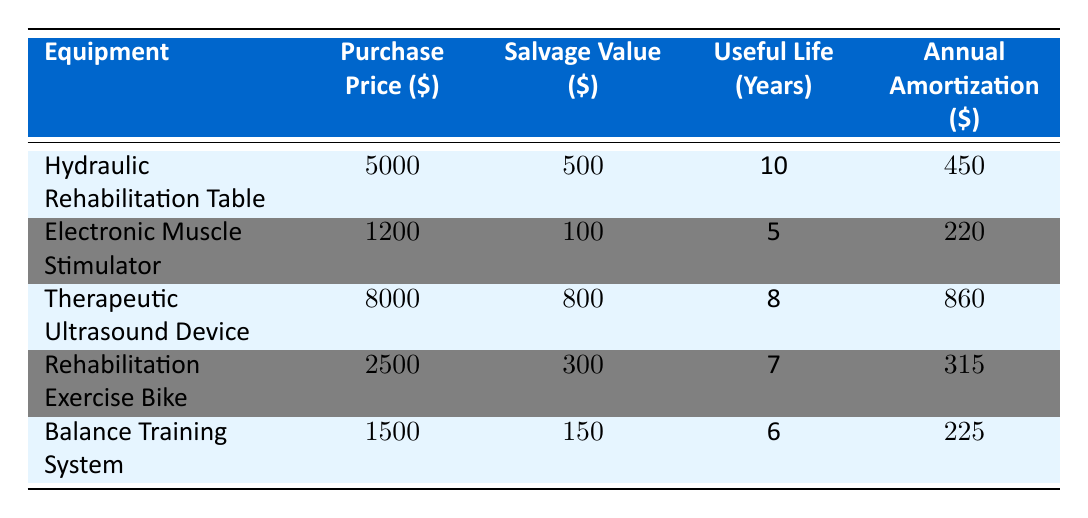What is the purchase price of the Hydraulic Rehabilitation Table? The purchase price column shows that the Hydraulic Rehabilitation Table has a purchase price of 5000.
Answer: 5000 What is the annual amortization for the Electronic Muscle Stimulator? Referring to the table, the annual amortization for the Electronic Muscle Stimulator is 220.
Answer: 220 Which equipment has the longest useful life? The table indicates that the Hydraulic Rehabilitation Table has the longest useful life of 10 years.
Answer: 10 years What is the total annual amortization for all the equipment? Adding up the annual amortization for all equipment: 450 + 220 + 860 + 315 + 225 = 2070.
Answer: 2070 Is the salvage value of the Rehabilitation Exercise Bike higher than that of the Balance Training System? The table shows that the salvage value of the Rehabilitation Exercise Bike is 300, while the Balance Training System has a salvage value of 150. Since 300 > 150, the statement is true.
Answer: Yes What is the average annual amortization of all equipment? To find the average, sum the annual amortization values (450 + 220 + 860 + 315 + 225 = 2070) and divide by the number of equipment (5): 2070 / 5 = 414.
Answer: 414 How much more is the purchase price of the Therapeutic Ultrasound Device compared to the Balance Training System? The purchase price of the Therapeutic Ultrasound Device is 8000, and the Balance Training System is 1500. The difference is 8000 - 1500 = 6500.
Answer: 6500 Which device has the highest annual amortization? Referring to the annual amortization values, the Therapeutic Ultrasound Device at 860 has the highest.
Answer: Therapeutic Ultrasound Device What is the total salvage value of all the equipment? The total salvage value is found by adding all the salvage values: 500 + 100 + 800 + 300 + 150 = 1850.
Answer: 1850 Does the Electronic Muscle Stimulator have a useful life longer than 5 years? The table lists the useful life of the Electronic Muscle Stimulator as 5 years. Therefore, it does not have a longer useful life than 5 years.
Answer: No 